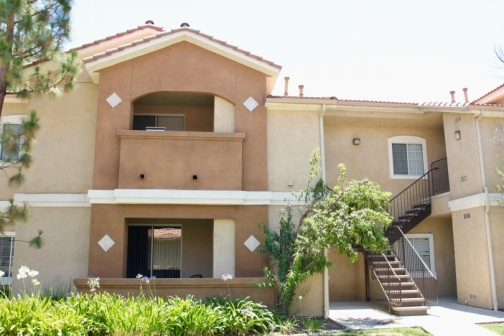If this was part of a historical scene, how would you describe the setting? If we envision this image as part of a historical scene, it could represent a period where suburban expansion was flourishing. The architecture with its terra cotta roof and beige exterior might reflect design trends from the early 20th century, emphasizing simplicity and harmony with nature. The well-maintained premises indicate a community that values order and aesthetics, possibly during an era when suburban living became synonymous with the American Dream. 